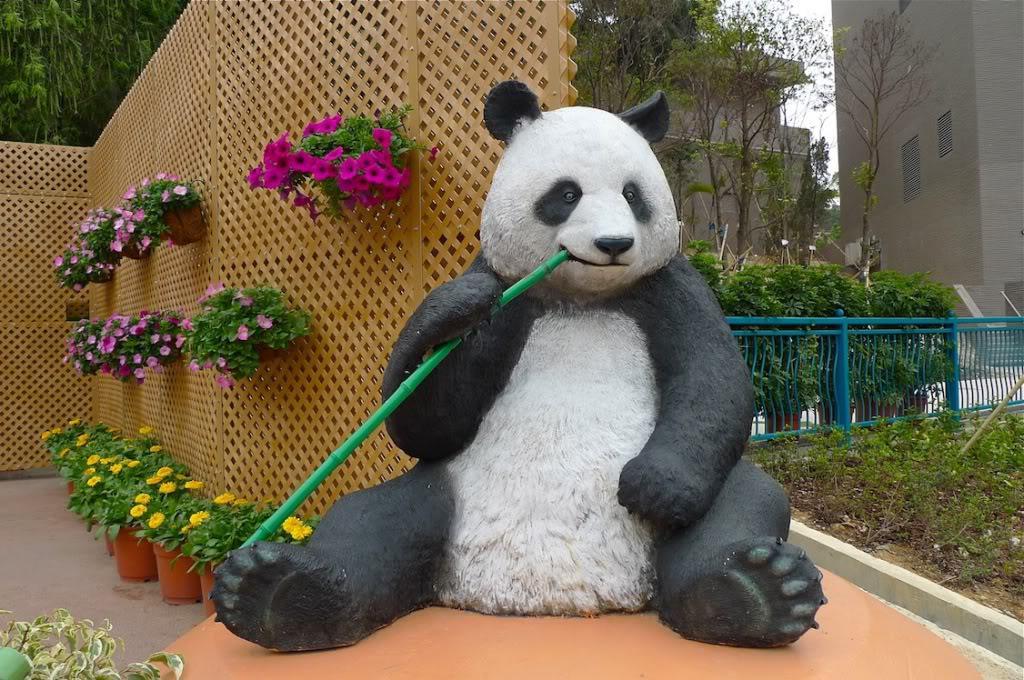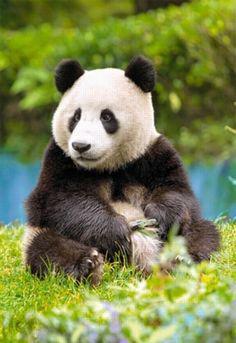The first image is the image on the left, the second image is the image on the right. Examine the images to the left and right. Is the description "The right image contains a panda with bamboo in its mouth." accurate? Answer yes or no. No. The first image is the image on the left, the second image is the image on the right. Assess this claim about the two images: "All pandas are sitting up, and at least one panda is munching on plant material grasped in one paw.". Correct or not? Answer yes or no. Yes. 